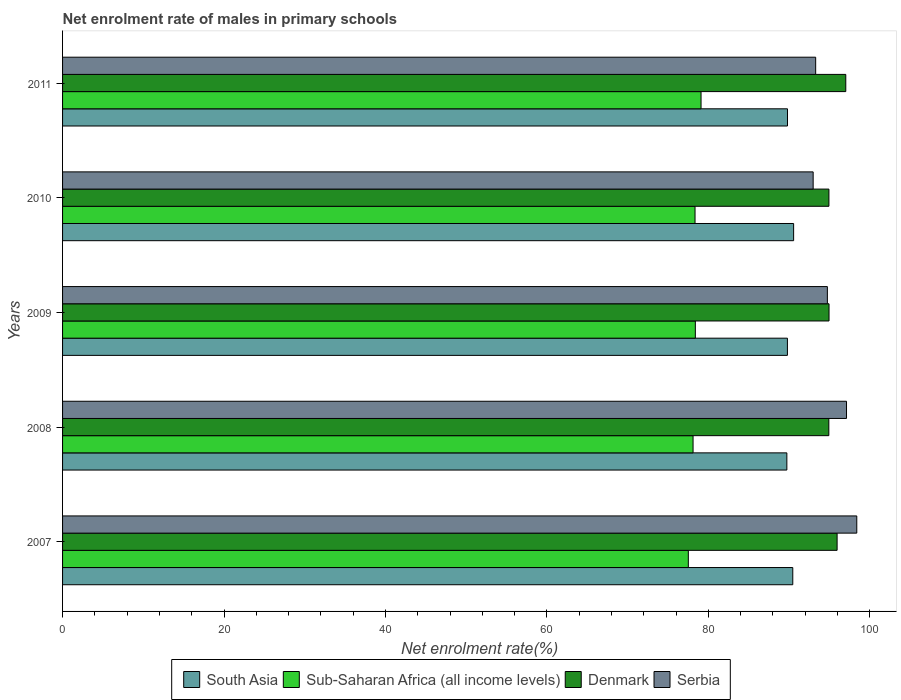How many different coloured bars are there?
Offer a terse response. 4. How many groups of bars are there?
Provide a succinct answer. 5. Are the number of bars per tick equal to the number of legend labels?
Your answer should be compact. Yes. How many bars are there on the 4th tick from the bottom?
Provide a short and direct response. 4. What is the label of the 4th group of bars from the top?
Provide a succinct answer. 2008. What is the net enrolment rate of males in primary schools in Sub-Saharan Africa (all income levels) in 2008?
Offer a terse response. 78.11. Across all years, what is the maximum net enrolment rate of males in primary schools in South Asia?
Keep it short and to the point. 90.57. Across all years, what is the minimum net enrolment rate of males in primary schools in Sub-Saharan Africa (all income levels)?
Ensure brevity in your answer.  77.53. What is the total net enrolment rate of males in primary schools in Sub-Saharan Africa (all income levels) in the graph?
Ensure brevity in your answer.  391.5. What is the difference between the net enrolment rate of males in primary schools in Denmark in 2008 and that in 2010?
Offer a very short reply. -0.01. What is the difference between the net enrolment rate of males in primary schools in Denmark in 2010 and the net enrolment rate of males in primary schools in Serbia in 2007?
Make the answer very short. -3.45. What is the average net enrolment rate of males in primary schools in Denmark per year?
Offer a very short reply. 95.57. In the year 2007, what is the difference between the net enrolment rate of males in primary schools in Sub-Saharan Africa (all income levels) and net enrolment rate of males in primary schools in Denmark?
Provide a short and direct response. -18.43. In how many years, is the net enrolment rate of males in primary schools in Denmark greater than 84 %?
Give a very brief answer. 5. What is the ratio of the net enrolment rate of males in primary schools in Denmark in 2007 to that in 2011?
Provide a succinct answer. 0.99. Is the net enrolment rate of males in primary schools in Sub-Saharan Africa (all income levels) in 2008 less than that in 2009?
Your response must be concise. Yes. What is the difference between the highest and the second highest net enrolment rate of males in primary schools in Denmark?
Keep it short and to the point. 1.07. What is the difference between the highest and the lowest net enrolment rate of males in primary schools in Denmark?
Make the answer very short. 2.1. What does the 1st bar from the top in 2010 represents?
Your answer should be very brief. Serbia. How many bars are there?
Give a very brief answer. 20. How many years are there in the graph?
Your answer should be very brief. 5. What is the difference between two consecutive major ticks on the X-axis?
Your answer should be very brief. 20. Are the values on the major ticks of X-axis written in scientific E-notation?
Your answer should be compact. No. Does the graph contain grids?
Offer a very short reply. No. Where does the legend appear in the graph?
Offer a very short reply. Bottom center. How many legend labels are there?
Make the answer very short. 4. What is the title of the graph?
Provide a short and direct response. Net enrolment rate of males in primary schools. What is the label or title of the X-axis?
Offer a terse response. Net enrolment rate(%). What is the Net enrolment rate(%) in South Asia in 2007?
Provide a short and direct response. 90.47. What is the Net enrolment rate(%) in Sub-Saharan Africa (all income levels) in 2007?
Offer a terse response. 77.53. What is the Net enrolment rate(%) in Denmark in 2007?
Your answer should be compact. 95.96. What is the Net enrolment rate(%) of Serbia in 2007?
Make the answer very short. 98.4. What is the Net enrolment rate(%) in South Asia in 2008?
Your response must be concise. 89.73. What is the Net enrolment rate(%) in Sub-Saharan Africa (all income levels) in 2008?
Offer a terse response. 78.11. What is the Net enrolment rate(%) of Denmark in 2008?
Offer a terse response. 94.93. What is the Net enrolment rate(%) of Serbia in 2008?
Provide a succinct answer. 97.13. What is the Net enrolment rate(%) in South Asia in 2009?
Offer a very short reply. 89.8. What is the Net enrolment rate(%) of Sub-Saharan Africa (all income levels) in 2009?
Give a very brief answer. 78.4. What is the Net enrolment rate(%) in Denmark in 2009?
Give a very brief answer. 94.96. What is the Net enrolment rate(%) of Serbia in 2009?
Offer a very short reply. 94.75. What is the Net enrolment rate(%) of South Asia in 2010?
Your response must be concise. 90.57. What is the Net enrolment rate(%) in Sub-Saharan Africa (all income levels) in 2010?
Offer a very short reply. 78.36. What is the Net enrolment rate(%) in Denmark in 2010?
Your answer should be very brief. 94.95. What is the Net enrolment rate(%) of Serbia in 2010?
Your answer should be very brief. 92.99. What is the Net enrolment rate(%) of South Asia in 2011?
Make the answer very short. 89.81. What is the Net enrolment rate(%) in Sub-Saharan Africa (all income levels) in 2011?
Your response must be concise. 79.1. What is the Net enrolment rate(%) in Denmark in 2011?
Your answer should be very brief. 97.03. What is the Net enrolment rate(%) in Serbia in 2011?
Your answer should be compact. 93.3. Across all years, what is the maximum Net enrolment rate(%) of South Asia?
Your response must be concise. 90.57. Across all years, what is the maximum Net enrolment rate(%) of Sub-Saharan Africa (all income levels)?
Keep it short and to the point. 79.1. Across all years, what is the maximum Net enrolment rate(%) of Denmark?
Offer a very short reply. 97.03. Across all years, what is the maximum Net enrolment rate(%) in Serbia?
Your answer should be compact. 98.4. Across all years, what is the minimum Net enrolment rate(%) in South Asia?
Your response must be concise. 89.73. Across all years, what is the minimum Net enrolment rate(%) of Sub-Saharan Africa (all income levels)?
Offer a very short reply. 77.53. Across all years, what is the minimum Net enrolment rate(%) of Denmark?
Your answer should be very brief. 94.93. Across all years, what is the minimum Net enrolment rate(%) in Serbia?
Provide a short and direct response. 92.99. What is the total Net enrolment rate(%) in South Asia in the graph?
Your answer should be very brief. 450.39. What is the total Net enrolment rate(%) of Sub-Saharan Africa (all income levels) in the graph?
Give a very brief answer. 391.5. What is the total Net enrolment rate(%) in Denmark in the graph?
Your response must be concise. 477.83. What is the total Net enrolment rate(%) of Serbia in the graph?
Make the answer very short. 476.57. What is the difference between the Net enrolment rate(%) of South Asia in 2007 and that in 2008?
Your answer should be compact. 0.73. What is the difference between the Net enrolment rate(%) of Sub-Saharan Africa (all income levels) in 2007 and that in 2008?
Your response must be concise. -0.59. What is the difference between the Net enrolment rate(%) of Denmark in 2007 and that in 2008?
Your response must be concise. 1.02. What is the difference between the Net enrolment rate(%) in Serbia in 2007 and that in 2008?
Provide a succinct answer. 1.27. What is the difference between the Net enrolment rate(%) in South Asia in 2007 and that in 2009?
Offer a very short reply. 0.66. What is the difference between the Net enrolment rate(%) of Sub-Saharan Africa (all income levels) in 2007 and that in 2009?
Provide a succinct answer. -0.87. What is the difference between the Net enrolment rate(%) of Denmark in 2007 and that in 2009?
Your response must be concise. 1. What is the difference between the Net enrolment rate(%) in Serbia in 2007 and that in 2009?
Make the answer very short. 3.64. What is the difference between the Net enrolment rate(%) in South Asia in 2007 and that in 2010?
Offer a very short reply. -0.11. What is the difference between the Net enrolment rate(%) of Sub-Saharan Africa (all income levels) in 2007 and that in 2010?
Offer a terse response. -0.83. What is the difference between the Net enrolment rate(%) of Denmark in 2007 and that in 2010?
Provide a short and direct response. 1.01. What is the difference between the Net enrolment rate(%) in Serbia in 2007 and that in 2010?
Keep it short and to the point. 5.41. What is the difference between the Net enrolment rate(%) of South Asia in 2007 and that in 2011?
Your response must be concise. 0.65. What is the difference between the Net enrolment rate(%) in Sub-Saharan Africa (all income levels) in 2007 and that in 2011?
Provide a succinct answer. -1.57. What is the difference between the Net enrolment rate(%) of Denmark in 2007 and that in 2011?
Offer a terse response. -1.07. What is the difference between the Net enrolment rate(%) in Serbia in 2007 and that in 2011?
Your answer should be very brief. 5.09. What is the difference between the Net enrolment rate(%) in South Asia in 2008 and that in 2009?
Provide a succinct answer. -0.07. What is the difference between the Net enrolment rate(%) of Sub-Saharan Africa (all income levels) in 2008 and that in 2009?
Your response must be concise. -0.28. What is the difference between the Net enrolment rate(%) in Denmark in 2008 and that in 2009?
Your response must be concise. -0.02. What is the difference between the Net enrolment rate(%) of Serbia in 2008 and that in 2009?
Make the answer very short. 2.37. What is the difference between the Net enrolment rate(%) of South Asia in 2008 and that in 2010?
Ensure brevity in your answer.  -0.84. What is the difference between the Net enrolment rate(%) of Sub-Saharan Africa (all income levels) in 2008 and that in 2010?
Keep it short and to the point. -0.24. What is the difference between the Net enrolment rate(%) of Denmark in 2008 and that in 2010?
Your response must be concise. -0.01. What is the difference between the Net enrolment rate(%) in Serbia in 2008 and that in 2010?
Provide a short and direct response. 4.13. What is the difference between the Net enrolment rate(%) of South Asia in 2008 and that in 2011?
Your answer should be compact. -0.08. What is the difference between the Net enrolment rate(%) in Sub-Saharan Africa (all income levels) in 2008 and that in 2011?
Your answer should be very brief. -0.99. What is the difference between the Net enrolment rate(%) in Denmark in 2008 and that in 2011?
Offer a very short reply. -2.1. What is the difference between the Net enrolment rate(%) in Serbia in 2008 and that in 2011?
Keep it short and to the point. 3.82. What is the difference between the Net enrolment rate(%) of South Asia in 2009 and that in 2010?
Your response must be concise. -0.77. What is the difference between the Net enrolment rate(%) of Sub-Saharan Africa (all income levels) in 2009 and that in 2010?
Provide a short and direct response. 0.04. What is the difference between the Net enrolment rate(%) in Denmark in 2009 and that in 2010?
Give a very brief answer. 0.01. What is the difference between the Net enrolment rate(%) of Serbia in 2009 and that in 2010?
Your answer should be compact. 1.76. What is the difference between the Net enrolment rate(%) in South Asia in 2009 and that in 2011?
Ensure brevity in your answer.  -0.01. What is the difference between the Net enrolment rate(%) in Sub-Saharan Africa (all income levels) in 2009 and that in 2011?
Your answer should be very brief. -0.71. What is the difference between the Net enrolment rate(%) in Denmark in 2009 and that in 2011?
Provide a short and direct response. -2.08. What is the difference between the Net enrolment rate(%) of Serbia in 2009 and that in 2011?
Make the answer very short. 1.45. What is the difference between the Net enrolment rate(%) of South Asia in 2010 and that in 2011?
Keep it short and to the point. 0.76. What is the difference between the Net enrolment rate(%) in Sub-Saharan Africa (all income levels) in 2010 and that in 2011?
Ensure brevity in your answer.  -0.74. What is the difference between the Net enrolment rate(%) of Denmark in 2010 and that in 2011?
Offer a terse response. -2.09. What is the difference between the Net enrolment rate(%) of Serbia in 2010 and that in 2011?
Keep it short and to the point. -0.31. What is the difference between the Net enrolment rate(%) of South Asia in 2007 and the Net enrolment rate(%) of Sub-Saharan Africa (all income levels) in 2008?
Make the answer very short. 12.35. What is the difference between the Net enrolment rate(%) in South Asia in 2007 and the Net enrolment rate(%) in Denmark in 2008?
Provide a succinct answer. -4.47. What is the difference between the Net enrolment rate(%) of South Asia in 2007 and the Net enrolment rate(%) of Serbia in 2008?
Ensure brevity in your answer.  -6.66. What is the difference between the Net enrolment rate(%) of Sub-Saharan Africa (all income levels) in 2007 and the Net enrolment rate(%) of Denmark in 2008?
Your answer should be compact. -17.41. What is the difference between the Net enrolment rate(%) of Sub-Saharan Africa (all income levels) in 2007 and the Net enrolment rate(%) of Serbia in 2008?
Ensure brevity in your answer.  -19.6. What is the difference between the Net enrolment rate(%) in Denmark in 2007 and the Net enrolment rate(%) in Serbia in 2008?
Provide a short and direct response. -1.17. What is the difference between the Net enrolment rate(%) in South Asia in 2007 and the Net enrolment rate(%) in Sub-Saharan Africa (all income levels) in 2009?
Give a very brief answer. 12.07. What is the difference between the Net enrolment rate(%) of South Asia in 2007 and the Net enrolment rate(%) of Denmark in 2009?
Your answer should be very brief. -4.49. What is the difference between the Net enrolment rate(%) in South Asia in 2007 and the Net enrolment rate(%) in Serbia in 2009?
Offer a very short reply. -4.29. What is the difference between the Net enrolment rate(%) in Sub-Saharan Africa (all income levels) in 2007 and the Net enrolment rate(%) in Denmark in 2009?
Provide a succinct answer. -17.43. What is the difference between the Net enrolment rate(%) in Sub-Saharan Africa (all income levels) in 2007 and the Net enrolment rate(%) in Serbia in 2009?
Your response must be concise. -17.23. What is the difference between the Net enrolment rate(%) of Denmark in 2007 and the Net enrolment rate(%) of Serbia in 2009?
Keep it short and to the point. 1.21. What is the difference between the Net enrolment rate(%) of South Asia in 2007 and the Net enrolment rate(%) of Sub-Saharan Africa (all income levels) in 2010?
Ensure brevity in your answer.  12.11. What is the difference between the Net enrolment rate(%) of South Asia in 2007 and the Net enrolment rate(%) of Denmark in 2010?
Offer a terse response. -4.48. What is the difference between the Net enrolment rate(%) in South Asia in 2007 and the Net enrolment rate(%) in Serbia in 2010?
Your answer should be very brief. -2.52. What is the difference between the Net enrolment rate(%) of Sub-Saharan Africa (all income levels) in 2007 and the Net enrolment rate(%) of Denmark in 2010?
Your answer should be very brief. -17.42. What is the difference between the Net enrolment rate(%) of Sub-Saharan Africa (all income levels) in 2007 and the Net enrolment rate(%) of Serbia in 2010?
Offer a terse response. -15.46. What is the difference between the Net enrolment rate(%) of Denmark in 2007 and the Net enrolment rate(%) of Serbia in 2010?
Make the answer very short. 2.97. What is the difference between the Net enrolment rate(%) of South Asia in 2007 and the Net enrolment rate(%) of Sub-Saharan Africa (all income levels) in 2011?
Give a very brief answer. 11.37. What is the difference between the Net enrolment rate(%) in South Asia in 2007 and the Net enrolment rate(%) in Denmark in 2011?
Your response must be concise. -6.57. What is the difference between the Net enrolment rate(%) of South Asia in 2007 and the Net enrolment rate(%) of Serbia in 2011?
Your answer should be compact. -2.84. What is the difference between the Net enrolment rate(%) in Sub-Saharan Africa (all income levels) in 2007 and the Net enrolment rate(%) in Denmark in 2011?
Your response must be concise. -19.51. What is the difference between the Net enrolment rate(%) of Sub-Saharan Africa (all income levels) in 2007 and the Net enrolment rate(%) of Serbia in 2011?
Keep it short and to the point. -15.78. What is the difference between the Net enrolment rate(%) of Denmark in 2007 and the Net enrolment rate(%) of Serbia in 2011?
Ensure brevity in your answer.  2.66. What is the difference between the Net enrolment rate(%) of South Asia in 2008 and the Net enrolment rate(%) of Sub-Saharan Africa (all income levels) in 2009?
Your response must be concise. 11.34. What is the difference between the Net enrolment rate(%) in South Asia in 2008 and the Net enrolment rate(%) in Denmark in 2009?
Keep it short and to the point. -5.22. What is the difference between the Net enrolment rate(%) of South Asia in 2008 and the Net enrolment rate(%) of Serbia in 2009?
Make the answer very short. -5.02. What is the difference between the Net enrolment rate(%) of Sub-Saharan Africa (all income levels) in 2008 and the Net enrolment rate(%) of Denmark in 2009?
Your answer should be very brief. -16.85. What is the difference between the Net enrolment rate(%) in Sub-Saharan Africa (all income levels) in 2008 and the Net enrolment rate(%) in Serbia in 2009?
Make the answer very short. -16.64. What is the difference between the Net enrolment rate(%) in Denmark in 2008 and the Net enrolment rate(%) in Serbia in 2009?
Provide a succinct answer. 0.18. What is the difference between the Net enrolment rate(%) of South Asia in 2008 and the Net enrolment rate(%) of Sub-Saharan Africa (all income levels) in 2010?
Make the answer very short. 11.38. What is the difference between the Net enrolment rate(%) in South Asia in 2008 and the Net enrolment rate(%) in Denmark in 2010?
Offer a terse response. -5.21. What is the difference between the Net enrolment rate(%) of South Asia in 2008 and the Net enrolment rate(%) of Serbia in 2010?
Your answer should be very brief. -3.26. What is the difference between the Net enrolment rate(%) of Sub-Saharan Africa (all income levels) in 2008 and the Net enrolment rate(%) of Denmark in 2010?
Keep it short and to the point. -16.83. What is the difference between the Net enrolment rate(%) of Sub-Saharan Africa (all income levels) in 2008 and the Net enrolment rate(%) of Serbia in 2010?
Provide a short and direct response. -14.88. What is the difference between the Net enrolment rate(%) in Denmark in 2008 and the Net enrolment rate(%) in Serbia in 2010?
Ensure brevity in your answer.  1.94. What is the difference between the Net enrolment rate(%) of South Asia in 2008 and the Net enrolment rate(%) of Sub-Saharan Africa (all income levels) in 2011?
Your answer should be very brief. 10.63. What is the difference between the Net enrolment rate(%) in South Asia in 2008 and the Net enrolment rate(%) in Denmark in 2011?
Your answer should be compact. -7.3. What is the difference between the Net enrolment rate(%) of South Asia in 2008 and the Net enrolment rate(%) of Serbia in 2011?
Keep it short and to the point. -3.57. What is the difference between the Net enrolment rate(%) of Sub-Saharan Africa (all income levels) in 2008 and the Net enrolment rate(%) of Denmark in 2011?
Give a very brief answer. -18.92. What is the difference between the Net enrolment rate(%) of Sub-Saharan Africa (all income levels) in 2008 and the Net enrolment rate(%) of Serbia in 2011?
Your response must be concise. -15.19. What is the difference between the Net enrolment rate(%) of Denmark in 2008 and the Net enrolment rate(%) of Serbia in 2011?
Make the answer very short. 1.63. What is the difference between the Net enrolment rate(%) of South Asia in 2009 and the Net enrolment rate(%) of Sub-Saharan Africa (all income levels) in 2010?
Keep it short and to the point. 11.45. What is the difference between the Net enrolment rate(%) in South Asia in 2009 and the Net enrolment rate(%) in Denmark in 2010?
Give a very brief answer. -5.14. What is the difference between the Net enrolment rate(%) of South Asia in 2009 and the Net enrolment rate(%) of Serbia in 2010?
Your response must be concise. -3.19. What is the difference between the Net enrolment rate(%) of Sub-Saharan Africa (all income levels) in 2009 and the Net enrolment rate(%) of Denmark in 2010?
Provide a succinct answer. -16.55. What is the difference between the Net enrolment rate(%) of Sub-Saharan Africa (all income levels) in 2009 and the Net enrolment rate(%) of Serbia in 2010?
Your response must be concise. -14.6. What is the difference between the Net enrolment rate(%) in Denmark in 2009 and the Net enrolment rate(%) in Serbia in 2010?
Provide a succinct answer. 1.97. What is the difference between the Net enrolment rate(%) in South Asia in 2009 and the Net enrolment rate(%) in Sub-Saharan Africa (all income levels) in 2011?
Make the answer very short. 10.7. What is the difference between the Net enrolment rate(%) in South Asia in 2009 and the Net enrolment rate(%) in Denmark in 2011?
Your answer should be compact. -7.23. What is the difference between the Net enrolment rate(%) in South Asia in 2009 and the Net enrolment rate(%) in Serbia in 2011?
Your answer should be compact. -3.5. What is the difference between the Net enrolment rate(%) of Sub-Saharan Africa (all income levels) in 2009 and the Net enrolment rate(%) of Denmark in 2011?
Offer a terse response. -18.64. What is the difference between the Net enrolment rate(%) in Sub-Saharan Africa (all income levels) in 2009 and the Net enrolment rate(%) in Serbia in 2011?
Offer a very short reply. -14.91. What is the difference between the Net enrolment rate(%) of Denmark in 2009 and the Net enrolment rate(%) of Serbia in 2011?
Ensure brevity in your answer.  1.66. What is the difference between the Net enrolment rate(%) of South Asia in 2010 and the Net enrolment rate(%) of Sub-Saharan Africa (all income levels) in 2011?
Your answer should be very brief. 11.47. What is the difference between the Net enrolment rate(%) of South Asia in 2010 and the Net enrolment rate(%) of Denmark in 2011?
Provide a short and direct response. -6.46. What is the difference between the Net enrolment rate(%) in South Asia in 2010 and the Net enrolment rate(%) in Serbia in 2011?
Your answer should be compact. -2.73. What is the difference between the Net enrolment rate(%) of Sub-Saharan Africa (all income levels) in 2010 and the Net enrolment rate(%) of Denmark in 2011?
Make the answer very short. -18.68. What is the difference between the Net enrolment rate(%) in Sub-Saharan Africa (all income levels) in 2010 and the Net enrolment rate(%) in Serbia in 2011?
Your answer should be compact. -14.95. What is the difference between the Net enrolment rate(%) in Denmark in 2010 and the Net enrolment rate(%) in Serbia in 2011?
Provide a succinct answer. 1.64. What is the average Net enrolment rate(%) in South Asia per year?
Your answer should be compact. 90.08. What is the average Net enrolment rate(%) of Sub-Saharan Africa (all income levels) per year?
Your answer should be very brief. 78.3. What is the average Net enrolment rate(%) of Denmark per year?
Keep it short and to the point. 95.57. What is the average Net enrolment rate(%) in Serbia per year?
Provide a succinct answer. 95.31. In the year 2007, what is the difference between the Net enrolment rate(%) in South Asia and Net enrolment rate(%) in Sub-Saharan Africa (all income levels)?
Provide a succinct answer. 12.94. In the year 2007, what is the difference between the Net enrolment rate(%) of South Asia and Net enrolment rate(%) of Denmark?
Your answer should be very brief. -5.49. In the year 2007, what is the difference between the Net enrolment rate(%) of South Asia and Net enrolment rate(%) of Serbia?
Make the answer very short. -7.93. In the year 2007, what is the difference between the Net enrolment rate(%) of Sub-Saharan Africa (all income levels) and Net enrolment rate(%) of Denmark?
Give a very brief answer. -18.43. In the year 2007, what is the difference between the Net enrolment rate(%) of Sub-Saharan Africa (all income levels) and Net enrolment rate(%) of Serbia?
Make the answer very short. -20.87. In the year 2007, what is the difference between the Net enrolment rate(%) in Denmark and Net enrolment rate(%) in Serbia?
Offer a very short reply. -2.44. In the year 2008, what is the difference between the Net enrolment rate(%) of South Asia and Net enrolment rate(%) of Sub-Saharan Africa (all income levels)?
Provide a succinct answer. 11.62. In the year 2008, what is the difference between the Net enrolment rate(%) in South Asia and Net enrolment rate(%) in Denmark?
Make the answer very short. -5.2. In the year 2008, what is the difference between the Net enrolment rate(%) of South Asia and Net enrolment rate(%) of Serbia?
Provide a short and direct response. -7.39. In the year 2008, what is the difference between the Net enrolment rate(%) of Sub-Saharan Africa (all income levels) and Net enrolment rate(%) of Denmark?
Provide a short and direct response. -16.82. In the year 2008, what is the difference between the Net enrolment rate(%) in Sub-Saharan Africa (all income levels) and Net enrolment rate(%) in Serbia?
Your answer should be very brief. -19.01. In the year 2008, what is the difference between the Net enrolment rate(%) in Denmark and Net enrolment rate(%) in Serbia?
Your response must be concise. -2.19. In the year 2009, what is the difference between the Net enrolment rate(%) of South Asia and Net enrolment rate(%) of Sub-Saharan Africa (all income levels)?
Your response must be concise. 11.41. In the year 2009, what is the difference between the Net enrolment rate(%) of South Asia and Net enrolment rate(%) of Denmark?
Ensure brevity in your answer.  -5.15. In the year 2009, what is the difference between the Net enrolment rate(%) in South Asia and Net enrolment rate(%) in Serbia?
Your answer should be very brief. -4.95. In the year 2009, what is the difference between the Net enrolment rate(%) of Sub-Saharan Africa (all income levels) and Net enrolment rate(%) of Denmark?
Your answer should be compact. -16.56. In the year 2009, what is the difference between the Net enrolment rate(%) in Sub-Saharan Africa (all income levels) and Net enrolment rate(%) in Serbia?
Your answer should be compact. -16.36. In the year 2009, what is the difference between the Net enrolment rate(%) in Denmark and Net enrolment rate(%) in Serbia?
Your answer should be very brief. 0.2. In the year 2010, what is the difference between the Net enrolment rate(%) of South Asia and Net enrolment rate(%) of Sub-Saharan Africa (all income levels)?
Give a very brief answer. 12.22. In the year 2010, what is the difference between the Net enrolment rate(%) of South Asia and Net enrolment rate(%) of Denmark?
Make the answer very short. -4.37. In the year 2010, what is the difference between the Net enrolment rate(%) of South Asia and Net enrolment rate(%) of Serbia?
Make the answer very short. -2.42. In the year 2010, what is the difference between the Net enrolment rate(%) of Sub-Saharan Africa (all income levels) and Net enrolment rate(%) of Denmark?
Offer a very short reply. -16.59. In the year 2010, what is the difference between the Net enrolment rate(%) in Sub-Saharan Africa (all income levels) and Net enrolment rate(%) in Serbia?
Provide a short and direct response. -14.63. In the year 2010, what is the difference between the Net enrolment rate(%) of Denmark and Net enrolment rate(%) of Serbia?
Your response must be concise. 1.95. In the year 2011, what is the difference between the Net enrolment rate(%) of South Asia and Net enrolment rate(%) of Sub-Saharan Africa (all income levels)?
Offer a very short reply. 10.71. In the year 2011, what is the difference between the Net enrolment rate(%) in South Asia and Net enrolment rate(%) in Denmark?
Provide a succinct answer. -7.22. In the year 2011, what is the difference between the Net enrolment rate(%) of South Asia and Net enrolment rate(%) of Serbia?
Keep it short and to the point. -3.49. In the year 2011, what is the difference between the Net enrolment rate(%) in Sub-Saharan Africa (all income levels) and Net enrolment rate(%) in Denmark?
Keep it short and to the point. -17.93. In the year 2011, what is the difference between the Net enrolment rate(%) in Sub-Saharan Africa (all income levels) and Net enrolment rate(%) in Serbia?
Your answer should be very brief. -14.2. In the year 2011, what is the difference between the Net enrolment rate(%) of Denmark and Net enrolment rate(%) of Serbia?
Give a very brief answer. 3.73. What is the ratio of the Net enrolment rate(%) of South Asia in 2007 to that in 2008?
Your response must be concise. 1.01. What is the ratio of the Net enrolment rate(%) of Sub-Saharan Africa (all income levels) in 2007 to that in 2008?
Offer a terse response. 0.99. What is the ratio of the Net enrolment rate(%) of Denmark in 2007 to that in 2008?
Make the answer very short. 1.01. What is the ratio of the Net enrolment rate(%) in Serbia in 2007 to that in 2008?
Provide a short and direct response. 1.01. What is the ratio of the Net enrolment rate(%) of South Asia in 2007 to that in 2009?
Offer a terse response. 1.01. What is the ratio of the Net enrolment rate(%) in Sub-Saharan Africa (all income levels) in 2007 to that in 2009?
Give a very brief answer. 0.99. What is the ratio of the Net enrolment rate(%) in Denmark in 2007 to that in 2009?
Keep it short and to the point. 1.01. What is the ratio of the Net enrolment rate(%) of Serbia in 2007 to that in 2009?
Your answer should be compact. 1.04. What is the ratio of the Net enrolment rate(%) in South Asia in 2007 to that in 2010?
Keep it short and to the point. 1. What is the ratio of the Net enrolment rate(%) of Sub-Saharan Africa (all income levels) in 2007 to that in 2010?
Give a very brief answer. 0.99. What is the ratio of the Net enrolment rate(%) in Denmark in 2007 to that in 2010?
Make the answer very short. 1.01. What is the ratio of the Net enrolment rate(%) of Serbia in 2007 to that in 2010?
Offer a very short reply. 1.06. What is the ratio of the Net enrolment rate(%) of South Asia in 2007 to that in 2011?
Ensure brevity in your answer.  1.01. What is the ratio of the Net enrolment rate(%) of Sub-Saharan Africa (all income levels) in 2007 to that in 2011?
Provide a succinct answer. 0.98. What is the ratio of the Net enrolment rate(%) in Denmark in 2007 to that in 2011?
Your response must be concise. 0.99. What is the ratio of the Net enrolment rate(%) of Serbia in 2007 to that in 2011?
Offer a terse response. 1.05. What is the ratio of the Net enrolment rate(%) of South Asia in 2008 to that in 2009?
Keep it short and to the point. 1. What is the ratio of the Net enrolment rate(%) of Sub-Saharan Africa (all income levels) in 2008 to that in 2009?
Give a very brief answer. 1. What is the ratio of the Net enrolment rate(%) of Denmark in 2008 to that in 2010?
Provide a succinct answer. 1. What is the ratio of the Net enrolment rate(%) in Serbia in 2008 to that in 2010?
Keep it short and to the point. 1.04. What is the ratio of the Net enrolment rate(%) of Sub-Saharan Africa (all income levels) in 2008 to that in 2011?
Keep it short and to the point. 0.99. What is the ratio of the Net enrolment rate(%) in Denmark in 2008 to that in 2011?
Give a very brief answer. 0.98. What is the ratio of the Net enrolment rate(%) in Serbia in 2008 to that in 2011?
Ensure brevity in your answer.  1.04. What is the ratio of the Net enrolment rate(%) of South Asia in 2009 to that in 2010?
Provide a succinct answer. 0.99. What is the ratio of the Net enrolment rate(%) in Sub-Saharan Africa (all income levels) in 2009 to that in 2010?
Your response must be concise. 1. What is the ratio of the Net enrolment rate(%) of Serbia in 2009 to that in 2010?
Keep it short and to the point. 1.02. What is the ratio of the Net enrolment rate(%) of South Asia in 2009 to that in 2011?
Give a very brief answer. 1. What is the ratio of the Net enrolment rate(%) in Denmark in 2009 to that in 2011?
Provide a short and direct response. 0.98. What is the ratio of the Net enrolment rate(%) in Serbia in 2009 to that in 2011?
Offer a very short reply. 1.02. What is the ratio of the Net enrolment rate(%) in South Asia in 2010 to that in 2011?
Your answer should be compact. 1.01. What is the ratio of the Net enrolment rate(%) of Sub-Saharan Africa (all income levels) in 2010 to that in 2011?
Keep it short and to the point. 0.99. What is the ratio of the Net enrolment rate(%) of Denmark in 2010 to that in 2011?
Your answer should be compact. 0.98. What is the difference between the highest and the second highest Net enrolment rate(%) of South Asia?
Your answer should be very brief. 0.11. What is the difference between the highest and the second highest Net enrolment rate(%) in Sub-Saharan Africa (all income levels)?
Give a very brief answer. 0.71. What is the difference between the highest and the second highest Net enrolment rate(%) of Denmark?
Keep it short and to the point. 1.07. What is the difference between the highest and the second highest Net enrolment rate(%) of Serbia?
Make the answer very short. 1.27. What is the difference between the highest and the lowest Net enrolment rate(%) of South Asia?
Your answer should be compact. 0.84. What is the difference between the highest and the lowest Net enrolment rate(%) of Sub-Saharan Africa (all income levels)?
Provide a short and direct response. 1.57. What is the difference between the highest and the lowest Net enrolment rate(%) of Denmark?
Your answer should be very brief. 2.1. What is the difference between the highest and the lowest Net enrolment rate(%) in Serbia?
Ensure brevity in your answer.  5.41. 